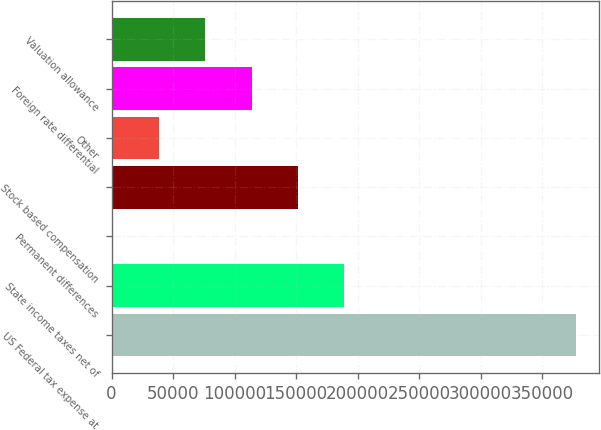Convert chart to OTSL. <chart><loc_0><loc_0><loc_500><loc_500><bar_chart><fcel>US Federal tax expense at<fcel>State income taxes net of<fcel>Permanent differences<fcel>Stock based compensation<fcel>Other<fcel>Foreign rate differential<fcel>Valuation allowance<nl><fcel>377599<fcel>189276<fcel>954<fcel>151612<fcel>38618.5<fcel>113948<fcel>76283<nl></chart> 